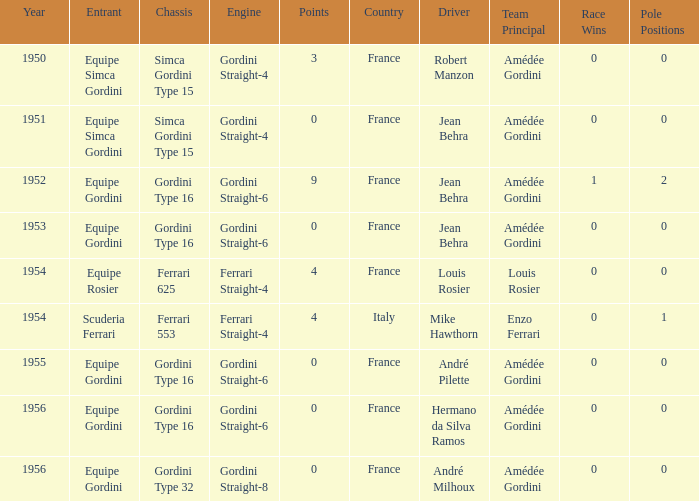Before 1956, what Chassis has Gordini Straight-4 engine with 3 points? Simca Gordini Type 15. 